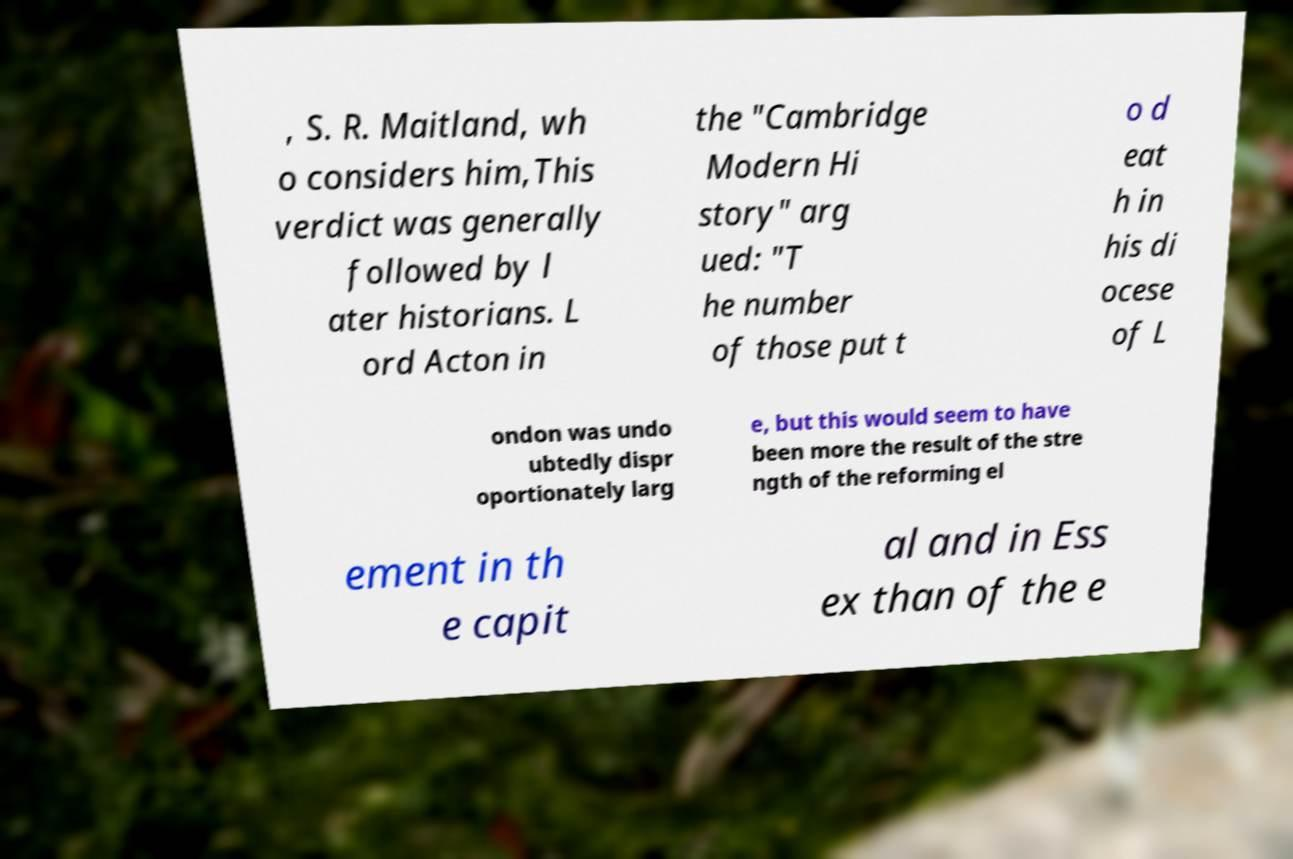What messages or text are displayed in this image? I need them in a readable, typed format. , S. R. Maitland, wh o considers him,This verdict was generally followed by l ater historians. L ord Acton in the "Cambridge Modern Hi story" arg ued: "T he number of those put t o d eat h in his di ocese of L ondon was undo ubtedly dispr oportionately larg e, but this would seem to have been more the result of the stre ngth of the reforming el ement in th e capit al and in Ess ex than of the e 